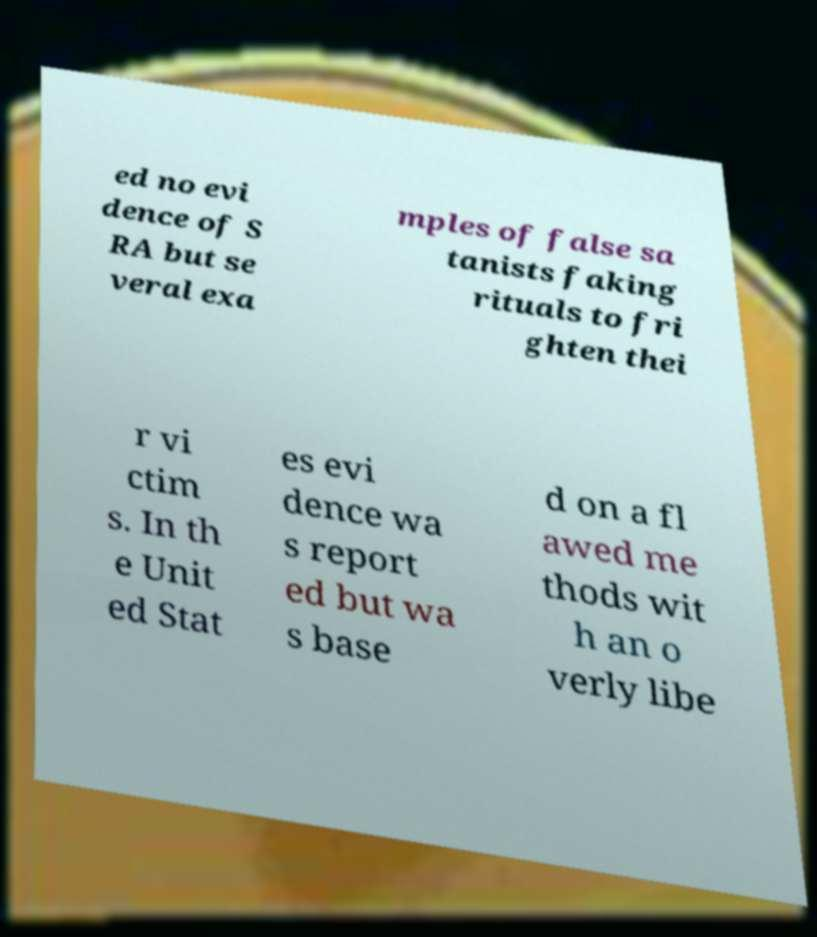Can you accurately transcribe the text from the provided image for me? ed no evi dence of S RA but se veral exa mples of false sa tanists faking rituals to fri ghten thei r vi ctim s. In th e Unit ed Stat es evi dence wa s report ed but wa s base d on a fl awed me thods wit h an o verly libe 